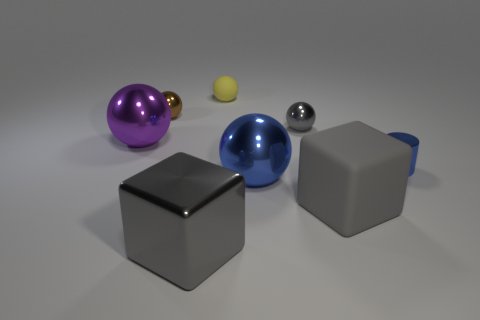Subtract all large purple shiny balls. How many balls are left? 4 Subtract 2 balls. How many balls are left? 3 Subtract all brown spheres. How many spheres are left? 4 Subtract all cyan balls. Subtract all purple cylinders. How many balls are left? 5 Add 2 big brown blocks. How many objects exist? 10 Subtract all spheres. How many objects are left? 3 Add 5 tiny yellow spheres. How many tiny yellow spheres exist? 6 Subtract 0 cyan cylinders. How many objects are left? 8 Subtract all large gray metal blocks. Subtract all small cylinders. How many objects are left? 6 Add 8 yellow matte objects. How many yellow matte objects are left? 9 